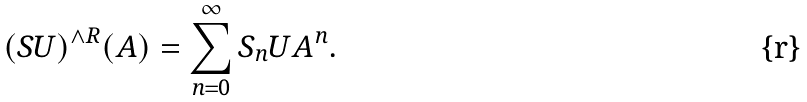Convert formula to latex. <formula><loc_0><loc_0><loc_500><loc_500>( S U ) ^ { \wedge R } ( A ) = \sum _ { n = 0 } ^ { \infty } S _ { n } U A ^ { n } .</formula> 